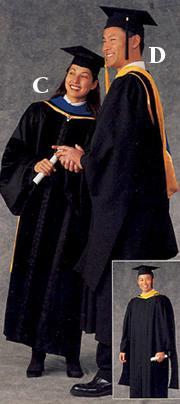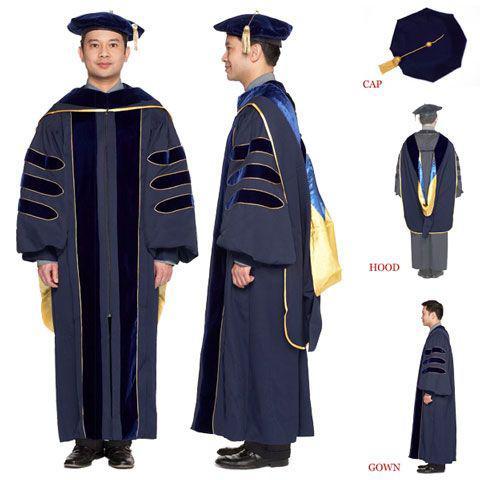The first image is the image on the left, the second image is the image on the right. Evaluate the accuracy of this statement regarding the images: "An image of a group of graduates includes a female with red hair and back turned to the camera.". Is it true? Answer yes or no. No. 